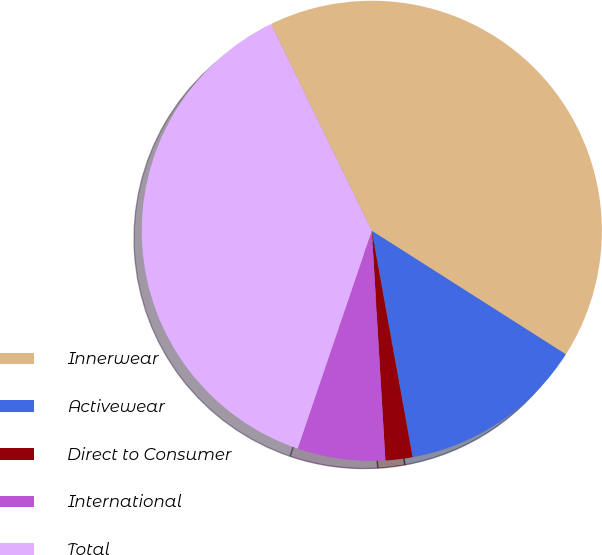Convert chart. <chart><loc_0><loc_0><loc_500><loc_500><pie_chart><fcel>Innerwear<fcel>Activewear<fcel>Direct to Consumer<fcel>International<fcel>Total<nl><fcel>41.24%<fcel>13.14%<fcel>1.9%<fcel>6.16%<fcel>37.57%<nl></chart> 